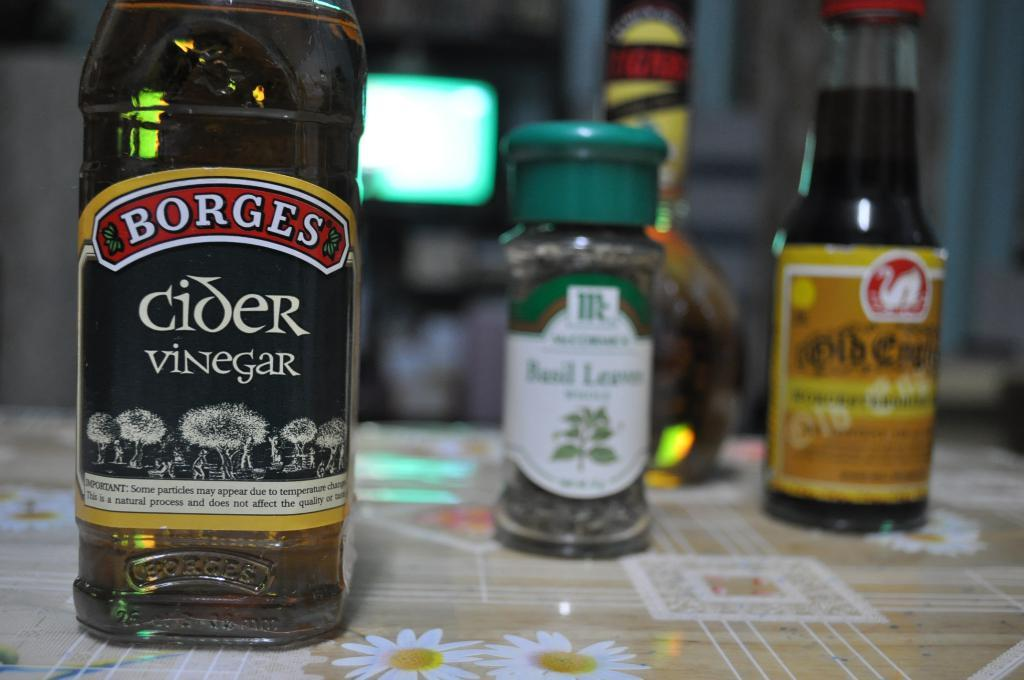Provide a one-sentence caption for the provided image. Black bottle of Cider Vinegar on a table next to some other condiments. 